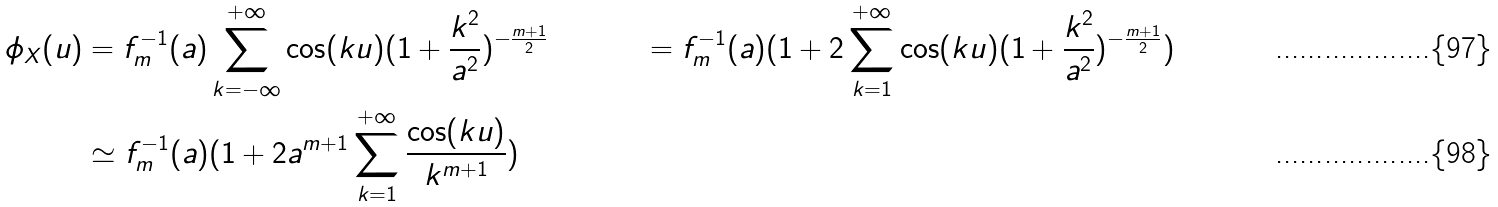Convert formula to latex. <formula><loc_0><loc_0><loc_500><loc_500>\phi _ { X } ( u ) & = f _ { m } ^ { - 1 } ( a ) \sum _ { k = - \infty } ^ { + \infty } \cos ( k u ) ( 1 + \frac { k ^ { 2 } } { a ^ { 2 } } ) ^ { - \frac { m + 1 } { 2 } } & = f _ { m } ^ { - 1 } ( a ) ( 1 + 2 \sum _ { k = 1 } ^ { + \infty } \cos ( k u ) ( 1 + \frac { k ^ { 2 } } { a ^ { 2 } } ) ^ { - \frac { m + 1 } { 2 } } ) \\ & \simeq f _ { m } ^ { - 1 } ( a ) ( 1 + 2 a ^ { m + 1 } \sum _ { k = 1 } ^ { + \infty } \frac { \cos ( k u ) } { k ^ { m + 1 } } )</formula> 